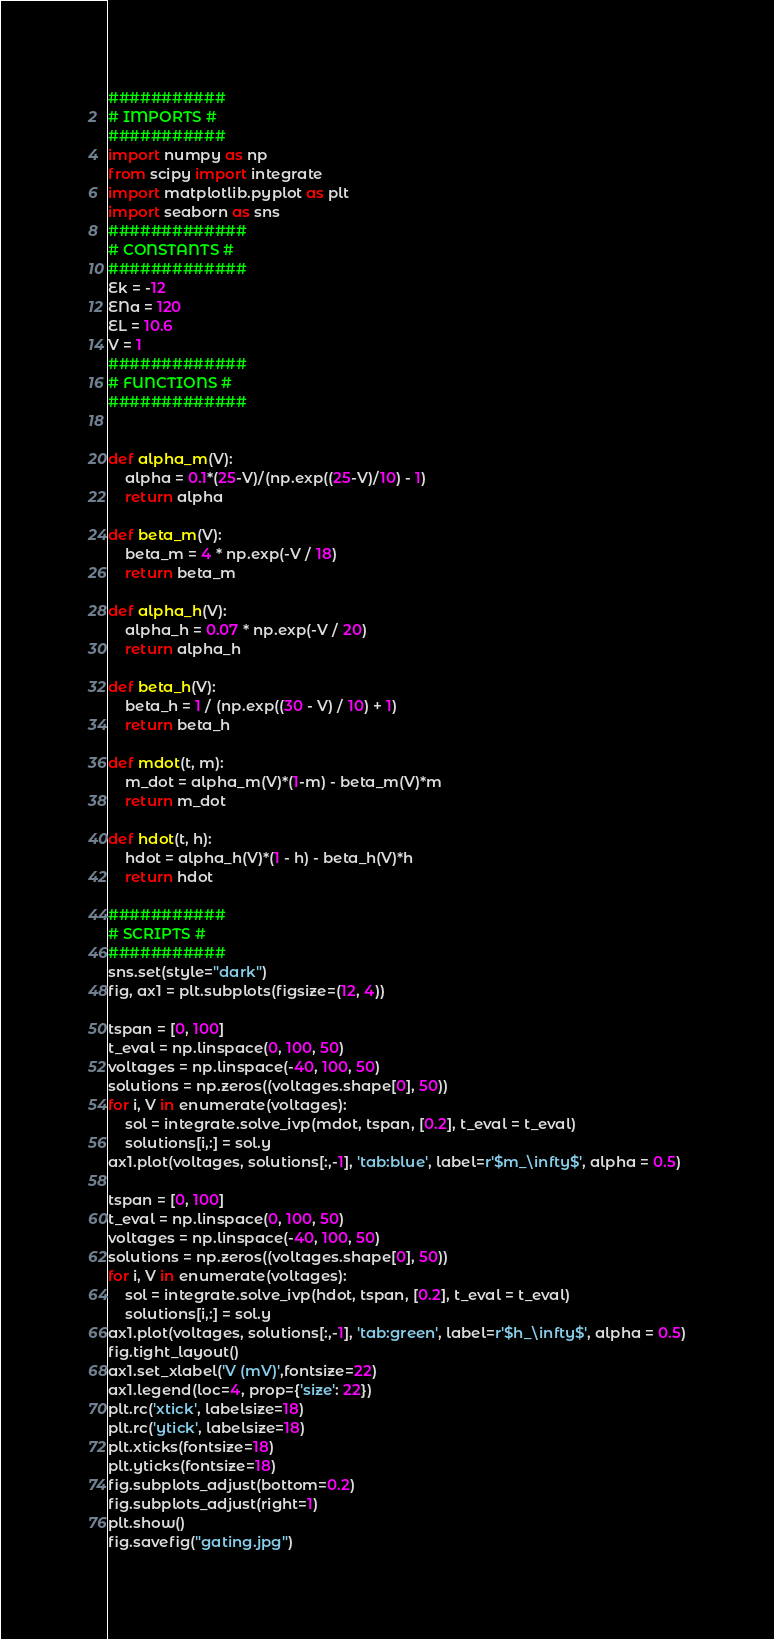Convert code to text. <code><loc_0><loc_0><loc_500><loc_500><_Python_>###########
# IMPORTS #
###########
import numpy as np
from scipy import integrate
import matplotlib.pyplot as plt
import seaborn as sns
#############
# CONSTANTS #
#############
Ek = -12
ENa = 120
EL = 10.6
V = 1
#############
# FUNCTIONS #
#############


def alpha_m(V):
    alpha = 0.1*(25-V)/(np.exp((25-V)/10) - 1)
    return alpha

def beta_m(V):
    beta_m = 4 * np.exp(-V / 18)
    return beta_m

def alpha_h(V):
    alpha_h = 0.07 * np.exp(-V / 20)
    return alpha_h

def beta_h(V):
    beta_h = 1 / (np.exp((30 - V) / 10) + 1)
    return beta_h

def mdot(t, m):
    m_dot = alpha_m(V)*(1-m) - beta_m(V)*m
    return m_dot

def hdot(t, h):
    hdot = alpha_h(V)*(1 - h) - beta_h(V)*h
    return hdot

###########
# SCRIPTS #
###########
sns.set(style="dark")
fig, ax1 = plt.subplots(figsize=(12, 4))

tspan = [0, 100]
t_eval = np.linspace(0, 100, 50)
voltages = np.linspace(-40, 100, 50)
solutions = np.zeros((voltages.shape[0], 50))
for i, V in enumerate(voltages):
    sol = integrate.solve_ivp(mdot, tspan, [0.2], t_eval = t_eval)
    solutions[i,:] = sol.y
ax1.plot(voltages, solutions[:,-1], 'tab:blue', label=r'$m_\infty$', alpha = 0.5)

tspan = [0, 100]
t_eval = np.linspace(0, 100, 50)
voltages = np.linspace(-40, 100, 50)
solutions = np.zeros((voltages.shape[0], 50))
for i, V in enumerate(voltages):
    sol = integrate.solve_ivp(hdot, tspan, [0.2], t_eval = t_eval)
    solutions[i,:] = sol.y
ax1.plot(voltages, solutions[:,-1], 'tab:green', label=r'$h_\infty$', alpha = 0.5)
fig.tight_layout()
ax1.set_xlabel('V (mV)',fontsize=22)
ax1.legend(loc=4, prop={'size': 22})
plt.rc('xtick', labelsize=18)
plt.rc('ytick', labelsize=18)
plt.xticks(fontsize=18)
plt.yticks(fontsize=18)
fig.subplots_adjust(bottom=0.2)
fig.subplots_adjust(right=1)
plt.show()
fig.savefig("gating.jpg")

</code> 